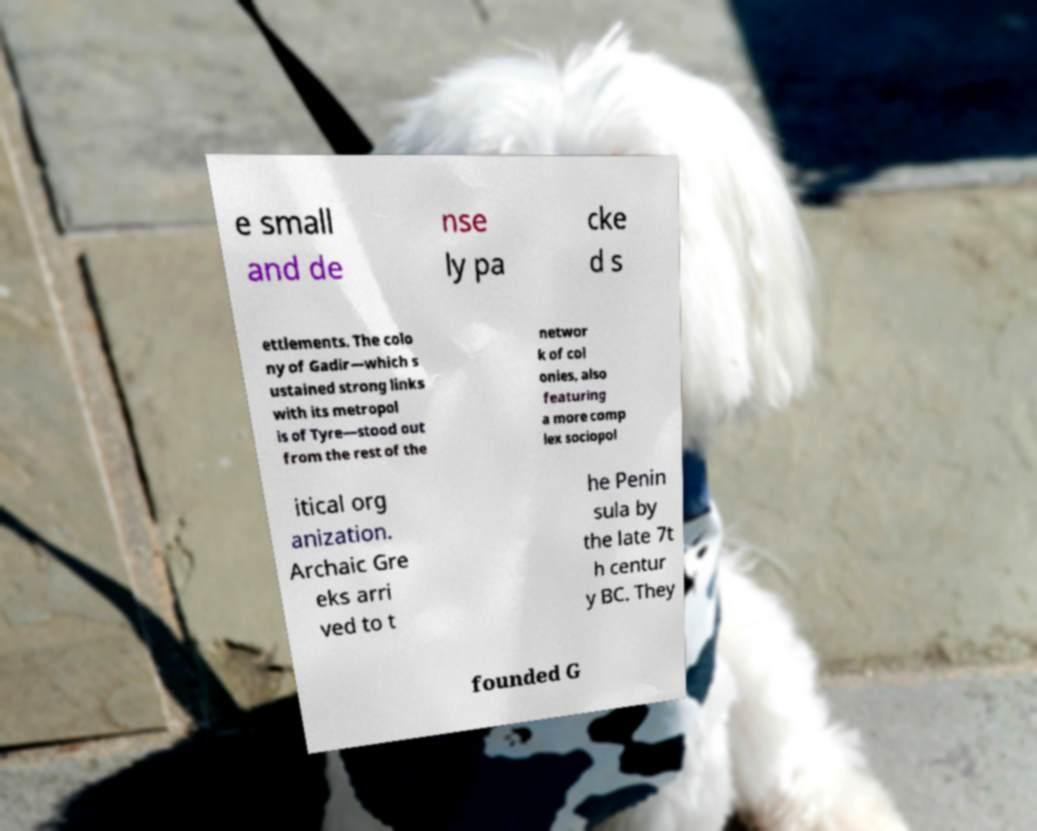Can you read and provide the text displayed in the image?This photo seems to have some interesting text. Can you extract and type it out for me? e small and de nse ly pa cke d s ettlements. The colo ny of Gadir—which s ustained strong links with its metropol is of Tyre—stood out from the rest of the networ k of col onies, also featuring a more comp lex sociopol itical org anization. Archaic Gre eks arri ved to t he Penin sula by the late 7t h centur y BC. They founded G 